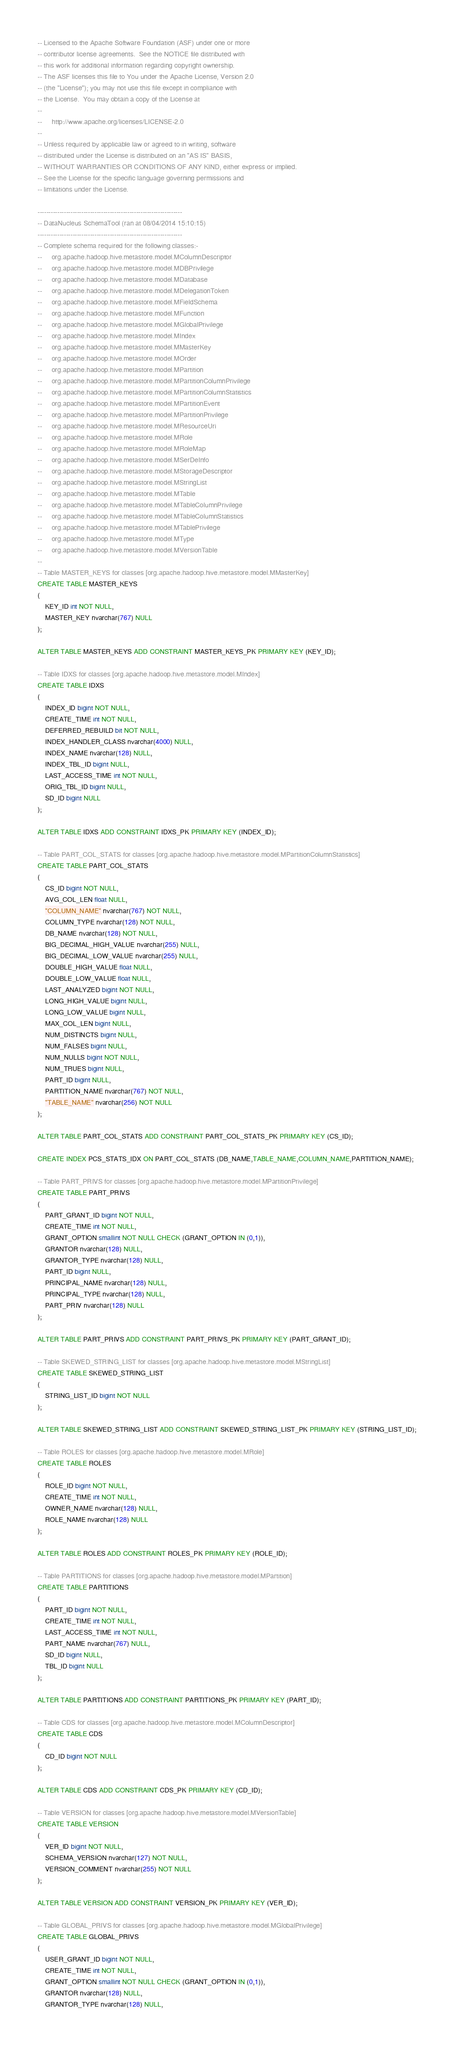<code> <loc_0><loc_0><loc_500><loc_500><_SQL_>-- Licensed to the Apache Software Foundation (ASF) under one or more
-- contributor license agreements.  See the NOTICE file distributed with
-- this work for additional information regarding copyright ownership.
-- The ASF licenses this file to You under the Apache License, Version 2.0
-- (the "License"); you may not use this file except in compliance with
-- the License.  You may obtain a copy of the License at
--
--     http://www.apache.org/licenses/LICENSE-2.0
--
-- Unless required by applicable law or agreed to in writing, software
-- distributed under the License is distributed on an "AS IS" BASIS,
-- WITHOUT WARRANTIES OR CONDITIONS OF ANY KIND, either express or implied.
-- See the License for the specific language governing permissions and
-- limitations under the License.

------------------------------------------------------------------
-- DataNucleus SchemaTool (ran at 08/04/2014 15:10:15)
------------------------------------------------------------------
-- Complete schema required for the following classes:-
--     org.apache.hadoop.hive.metastore.model.MColumnDescriptor
--     org.apache.hadoop.hive.metastore.model.MDBPrivilege
--     org.apache.hadoop.hive.metastore.model.MDatabase
--     org.apache.hadoop.hive.metastore.model.MDelegationToken
--     org.apache.hadoop.hive.metastore.model.MFieldSchema
--     org.apache.hadoop.hive.metastore.model.MFunction
--     org.apache.hadoop.hive.metastore.model.MGlobalPrivilege
--     org.apache.hadoop.hive.metastore.model.MIndex
--     org.apache.hadoop.hive.metastore.model.MMasterKey
--     org.apache.hadoop.hive.metastore.model.MOrder
--     org.apache.hadoop.hive.metastore.model.MPartition
--     org.apache.hadoop.hive.metastore.model.MPartitionColumnPrivilege
--     org.apache.hadoop.hive.metastore.model.MPartitionColumnStatistics
--     org.apache.hadoop.hive.metastore.model.MPartitionEvent
--     org.apache.hadoop.hive.metastore.model.MPartitionPrivilege
--     org.apache.hadoop.hive.metastore.model.MResourceUri
--     org.apache.hadoop.hive.metastore.model.MRole
--     org.apache.hadoop.hive.metastore.model.MRoleMap
--     org.apache.hadoop.hive.metastore.model.MSerDeInfo
--     org.apache.hadoop.hive.metastore.model.MStorageDescriptor
--     org.apache.hadoop.hive.metastore.model.MStringList
--     org.apache.hadoop.hive.metastore.model.MTable
--     org.apache.hadoop.hive.metastore.model.MTableColumnPrivilege
--     org.apache.hadoop.hive.metastore.model.MTableColumnStatistics
--     org.apache.hadoop.hive.metastore.model.MTablePrivilege
--     org.apache.hadoop.hive.metastore.model.MType
--     org.apache.hadoop.hive.metastore.model.MVersionTable
--
-- Table MASTER_KEYS for classes [org.apache.hadoop.hive.metastore.model.MMasterKey]
CREATE TABLE MASTER_KEYS
(
    KEY_ID int NOT NULL,
    MASTER_KEY nvarchar(767) NULL
);

ALTER TABLE MASTER_KEYS ADD CONSTRAINT MASTER_KEYS_PK PRIMARY KEY (KEY_ID);

-- Table IDXS for classes [org.apache.hadoop.hive.metastore.model.MIndex]
CREATE TABLE IDXS
(
    INDEX_ID bigint NOT NULL,
    CREATE_TIME int NOT NULL,
    DEFERRED_REBUILD bit NOT NULL,
    INDEX_HANDLER_CLASS nvarchar(4000) NULL,
    INDEX_NAME nvarchar(128) NULL,
    INDEX_TBL_ID bigint NULL,
    LAST_ACCESS_TIME int NOT NULL,
    ORIG_TBL_ID bigint NULL,
    SD_ID bigint NULL
);

ALTER TABLE IDXS ADD CONSTRAINT IDXS_PK PRIMARY KEY (INDEX_ID);

-- Table PART_COL_STATS for classes [org.apache.hadoop.hive.metastore.model.MPartitionColumnStatistics]
CREATE TABLE PART_COL_STATS
(
    CS_ID bigint NOT NULL,
    AVG_COL_LEN float NULL,
    "COLUMN_NAME" nvarchar(767) NOT NULL,
    COLUMN_TYPE nvarchar(128) NOT NULL,
    DB_NAME nvarchar(128) NOT NULL,
    BIG_DECIMAL_HIGH_VALUE nvarchar(255) NULL,
    BIG_DECIMAL_LOW_VALUE nvarchar(255) NULL,
    DOUBLE_HIGH_VALUE float NULL,
    DOUBLE_LOW_VALUE float NULL,
    LAST_ANALYZED bigint NOT NULL,
    LONG_HIGH_VALUE bigint NULL,
    LONG_LOW_VALUE bigint NULL,
    MAX_COL_LEN bigint NULL,
    NUM_DISTINCTS bigint NULL,
    NUM_FALSES bigint NULL,
    NUM_NULLS bigint NOT NULL,
    NUM_TRUES bigint NULL,
    PART_ID bigint NULL,
    PARTITION_NAME nvarchar(767) NOT NULL,
    "TABLE_NAME" nvarchar(256) NOT NULL
);

ALTER TABLE PART_COL_STATS ADD CONSTRAINT PART_COL_STATS_PK PRIMARY KEY (CS_ID);

CREATE INDEX PCS_STATS_IDX ON PART_COL_STATS (DB_NAME,TABLE_NAME,COLUMN_NAME,PARTITION_NAME);

-- Table PART_PRIVS for classes [org.apache.hadoop.hive.metastore.model.MPartitionPrivilege]
CREATE TABLE PART_PRIVS
(
    PART_GRANT_ID bigint NOT NULL,
    CREATE_TIME int NOT NULL,
    GRANT_OPTION smallint NOT NULL CHECK (GRANT_OPTION IN (0,1)),
    GRANTOR nvarchar(128) NULL,
    GRANTOR_TYPE nvarchar(128) NULL,
    PART_ID bigint NULL,
    PRINCIPAL_NAME nvarchar(128) NULL,
    PRINCIPAL_TYPE nvarchar(128) NULL,
    PART_PRIV nvarchar(128) NULL
);

ALTER TABLE PART_PRIVS ADD CONSTRAINT PART_PRIVS_PK PRIMARY KEY (PART_GRANT_ID);

-- Table SKEWED_STRING_LIST for classes [org.apache.hadoop.hive.metastore.model.MStringList]
CREATE TABLE SKEWED_STRING_LIST
(
    STRING_LIST_ID bigint NOT NULL
);

ALTER TABLE SKEWED_STRING_LIST ADD CONSTRAINT SKEWED_STRING_LIST_PK PRIMARY KEY (STRING_LIST_ID);

-- Table ROLES for classes [org.apache.hadoop.hive.metastore.model.MRole]
CREATE TABLE ROLES
(
    ROLE_ID bigint NOT NULL,
    CREATE_TIME int NOT NULL,
    OWNER_NAME nvarchar(128) NULL,
    ROLE_NAME nvarchar(128) NULL
);

ALTER TABLE ROLES ADD CONSTRAINT ROLES_PK PRIMARY KEY (ROLE_ID);

-- Table PARTITIONS for classes [org.apache.hadoop.hive.metastore.model.MPartition]
CREATE TABLE PARTITIONS
(
    PART_ID bigint NOT NULL,
    CREATE_TIME int NOT NULL,
    LAST_ACCESS_TIME int NOT NULL,
    PART_NAME nvarchar(767) NULL,
    SD_ID bigint NULL,
    TBL_ID bigint NULL
);

ALTER TABLE PARTITIONS ADD CONSTRAINT PARTITIONS_PK PRIMARY KEY (PART_ID);

-- Table CDS for classes [org.apache.hadoop.hive.metastore.model.MColumnDescriptor]
CREATE TABLE CDS
(
    CD_ID bigint NOT NULL
);

ALTER TABLE CDS ADD CONSTRAINT CDS_PK PRIMARY KEY (CD_ID);

-- Table VERSION for classes [org.apache.hadoop.hive.metastore.model.MVersionTable]
CREATE TABLE VERSION
(
    VER_ID bigint NOT NULL,
    SCHEMA_VERSION nvarchar(127) NOT NULL,
    VERSION_COMMENT nvarchar(255) NOT NULL
);

ALTER TABLE VERSION ADD CONSTRAINT VERSION_PK PRIMARY KEY (VER_ID);

-- Table GLOBAL_PRIVS for classes [org.apache.hadoop.hive.metastore.model.MGlobalPrivilege]
CREATE TABLE GLOBAL_PRIVS
(
    USER_GRANT_ID bigint NOT NULL,
    CREATE_TIME int NOT NULL,
    GRANT_OPTION smallint NOT NULL CHECK (GRANT_OPTION IN (0,1)),
    GRANTOR nvarchar(128) NULL,
    GRANTOR_TYPE nvarchar(128) NULL,</code> 